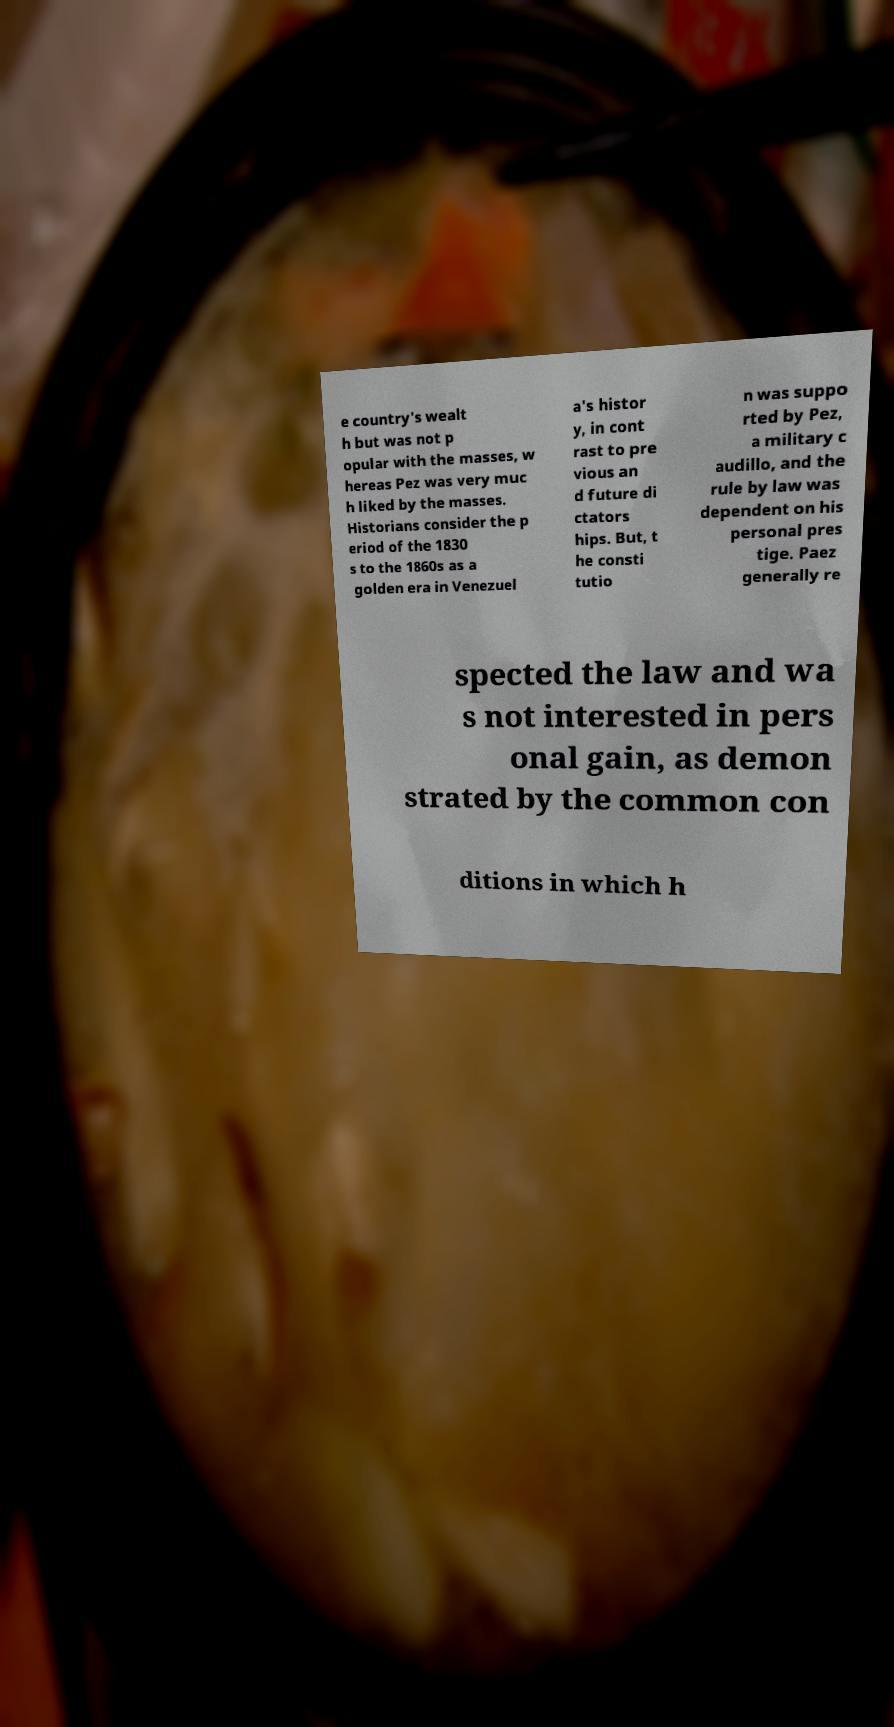Please identify and transcribe the text found in this image. e country's wealt h but was not p opular with the masses, w hereas Pez was very muc h liked by the masses. Historians consider the p eriod of the 1830 s to the 1860s as a golden era in Venezuel a's histor y, in cont rast to pre vious an d future di ctators hips. But, t he consti tutio n was suppo rted by Pez, a military c audillo, and the rule by law was dependent on his personal pres tige. Paez generally re spected the law and wa s not interested in pers onal gain, as demon strated by the common con ditions in which h 